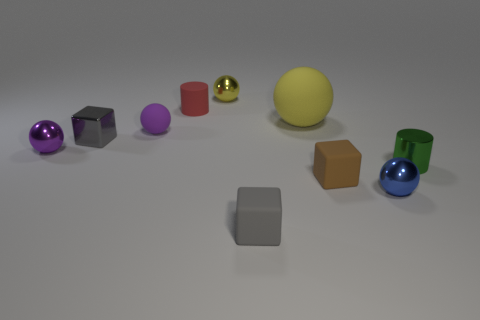What number of other objects are the same size as the green cylinder?
Provide a short and direct response. 8. Is there any other thing that is the same size as the yellow matte thing?
Offer a terse response. No. What number of blue spheres are the same size as the red cylinder?
Keep it short and to the point. 1. What is the material of the other gray object that is the same shape as the tiny gray rubber thing?
Keep it short and to the point. Metal. How many things are shiny spheres that are to the left of the brown object or tiny purple matte balls that are to the right of the small gray metal cube?
Your answer should be very brief. 3. There is a big yellow matte thing; is it the same shape as the small shiny thing that is behind the small metallic cube?
Offer a very short reply. Yes. What is the shape of the blue metallic thing in front of the small shiny ball that is left of the small red matte thing that is left of the large rubber sphere?
Your answer should be compact. Sphere. How many other objects are the same material as the tiny blue sphere?
Your answer should be very brief. 4. What number of things are tiny spheres that are in front of the tiny green metal cylinder or small purple spheres?
Offer a very short reply. 3. What is the shape of the tiny gray thing that is to the right of the purple sphere that is right of the purple shiny object?
Keep it short and to the point. Cube. 